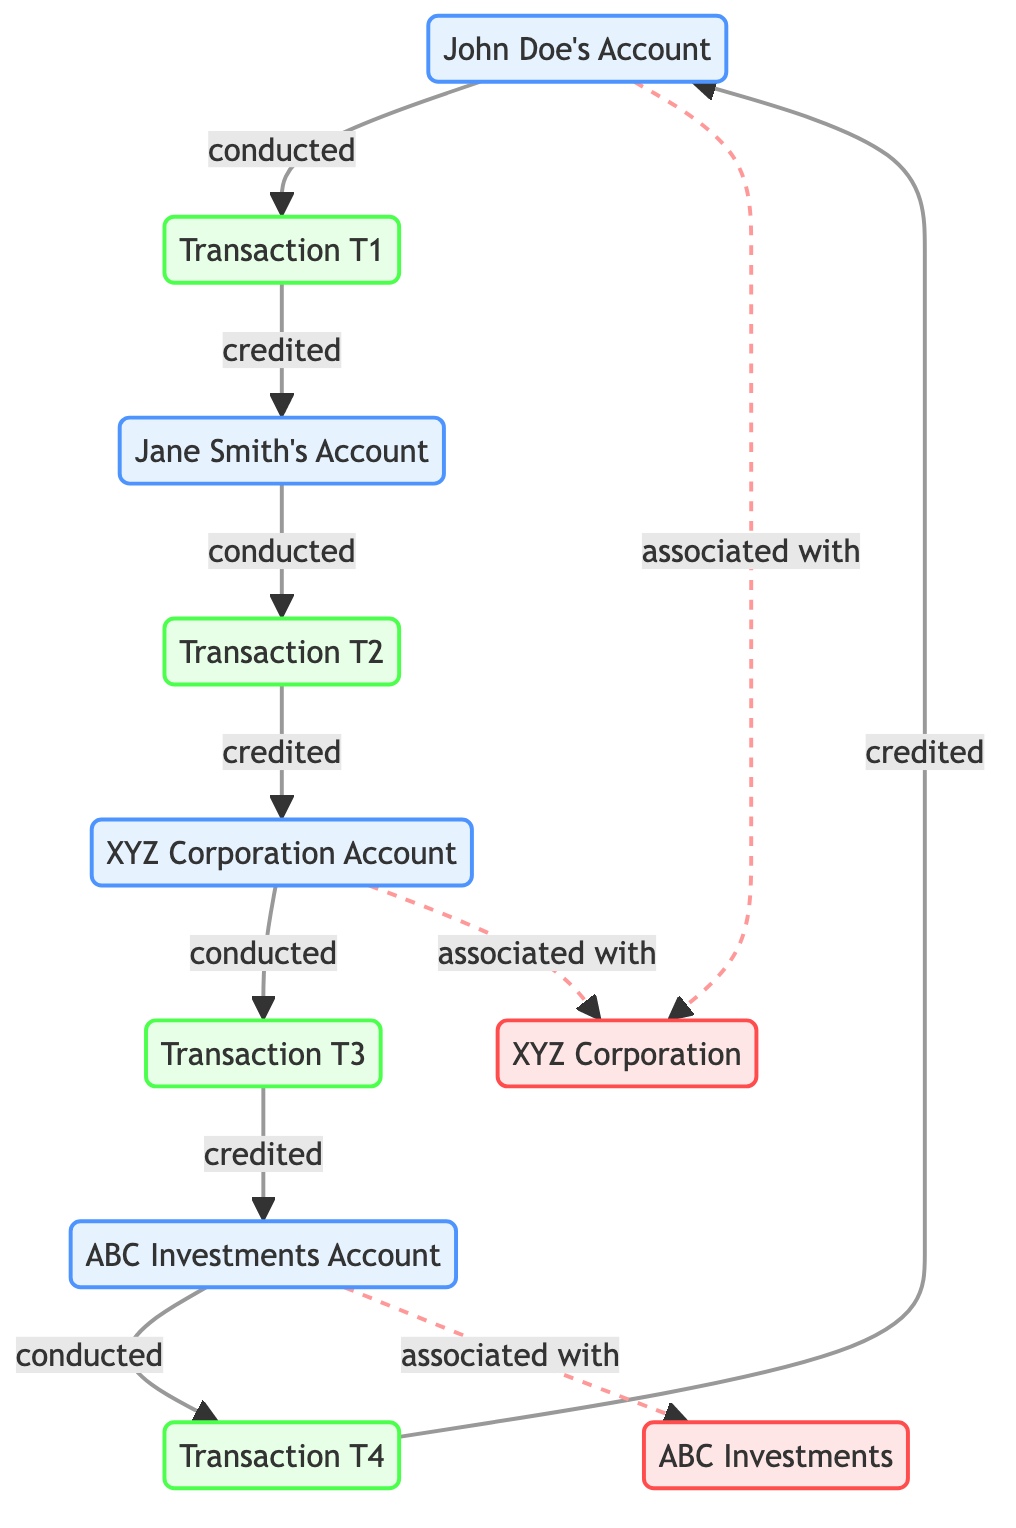What are the total number of bank accounts in the diagram? The diagram lists four bank accounts, specifically: John Doe's Account, Jane Smith's Account, XYZ Corporation Account, and ABC Investments Account.
Answer: 4 Who conducted Transaction T1? Transaction T1 is conducted by John Doe's Account, as indicated by the directed edge leading into the transaction from this node.
Answer: John Doe's Account How many financial transactions are shown in the diagram? There are four financial transactions labeled as Transaction T1, Transaction T2, Transaction T3, and Transaction T4. Each one reflects a distinct edge showing the flow of funds.
Answer: 4 Which account is associated with ABC Investments? The diagram shows that ABC Investments Account is the account associated with ABC Investments, indicated by the dashed line connecting the two.
Answer: ABC Investments Account What is the sequence of transactions starting from John Doe's Account? The sequence begins at John Doe's Account, leading to Transaction T1, then credited to Jane Smith's Account, which conducts Transaction T2, credited to XYZ Corporation Account, which then conducts Transaction T3, credited to ABC Investments Account, which conducts Transaction T4, and finally credited back to John Doe's Account.
Answer: John Doe's Account → Transaction T1 → Jane Smith's Account → Transaction T2 → XYZ Corporation Account → Transaction T3 → ABC Investments Account → Transaction T4 → John Doe's Account Which corporations are associated with the bank accounts? The corporations are XYZ Corporation and ABC Investments, with associations to their respective accounts as indicated by the dashed lines connecting the accounts to the companies.
Answer: XYZ Corporation, ABC Investments How many total edges are in this diagram? The diagram features a total of ten edges, including connections for transactions and association lines between accounts and companies.
Answer: 10 What is the flow of funds from XYZ Corporation Account? Funds flow from XYZ Corporation Account through the conducting of Transaction T3, which credits ABC Investments Account. The process entails the XYZ Corporation Account conducting the transaction before the funds are credited accordingly.
Answer: XYZ Corporation Account → Transaction T3 → ABC Investments Account 